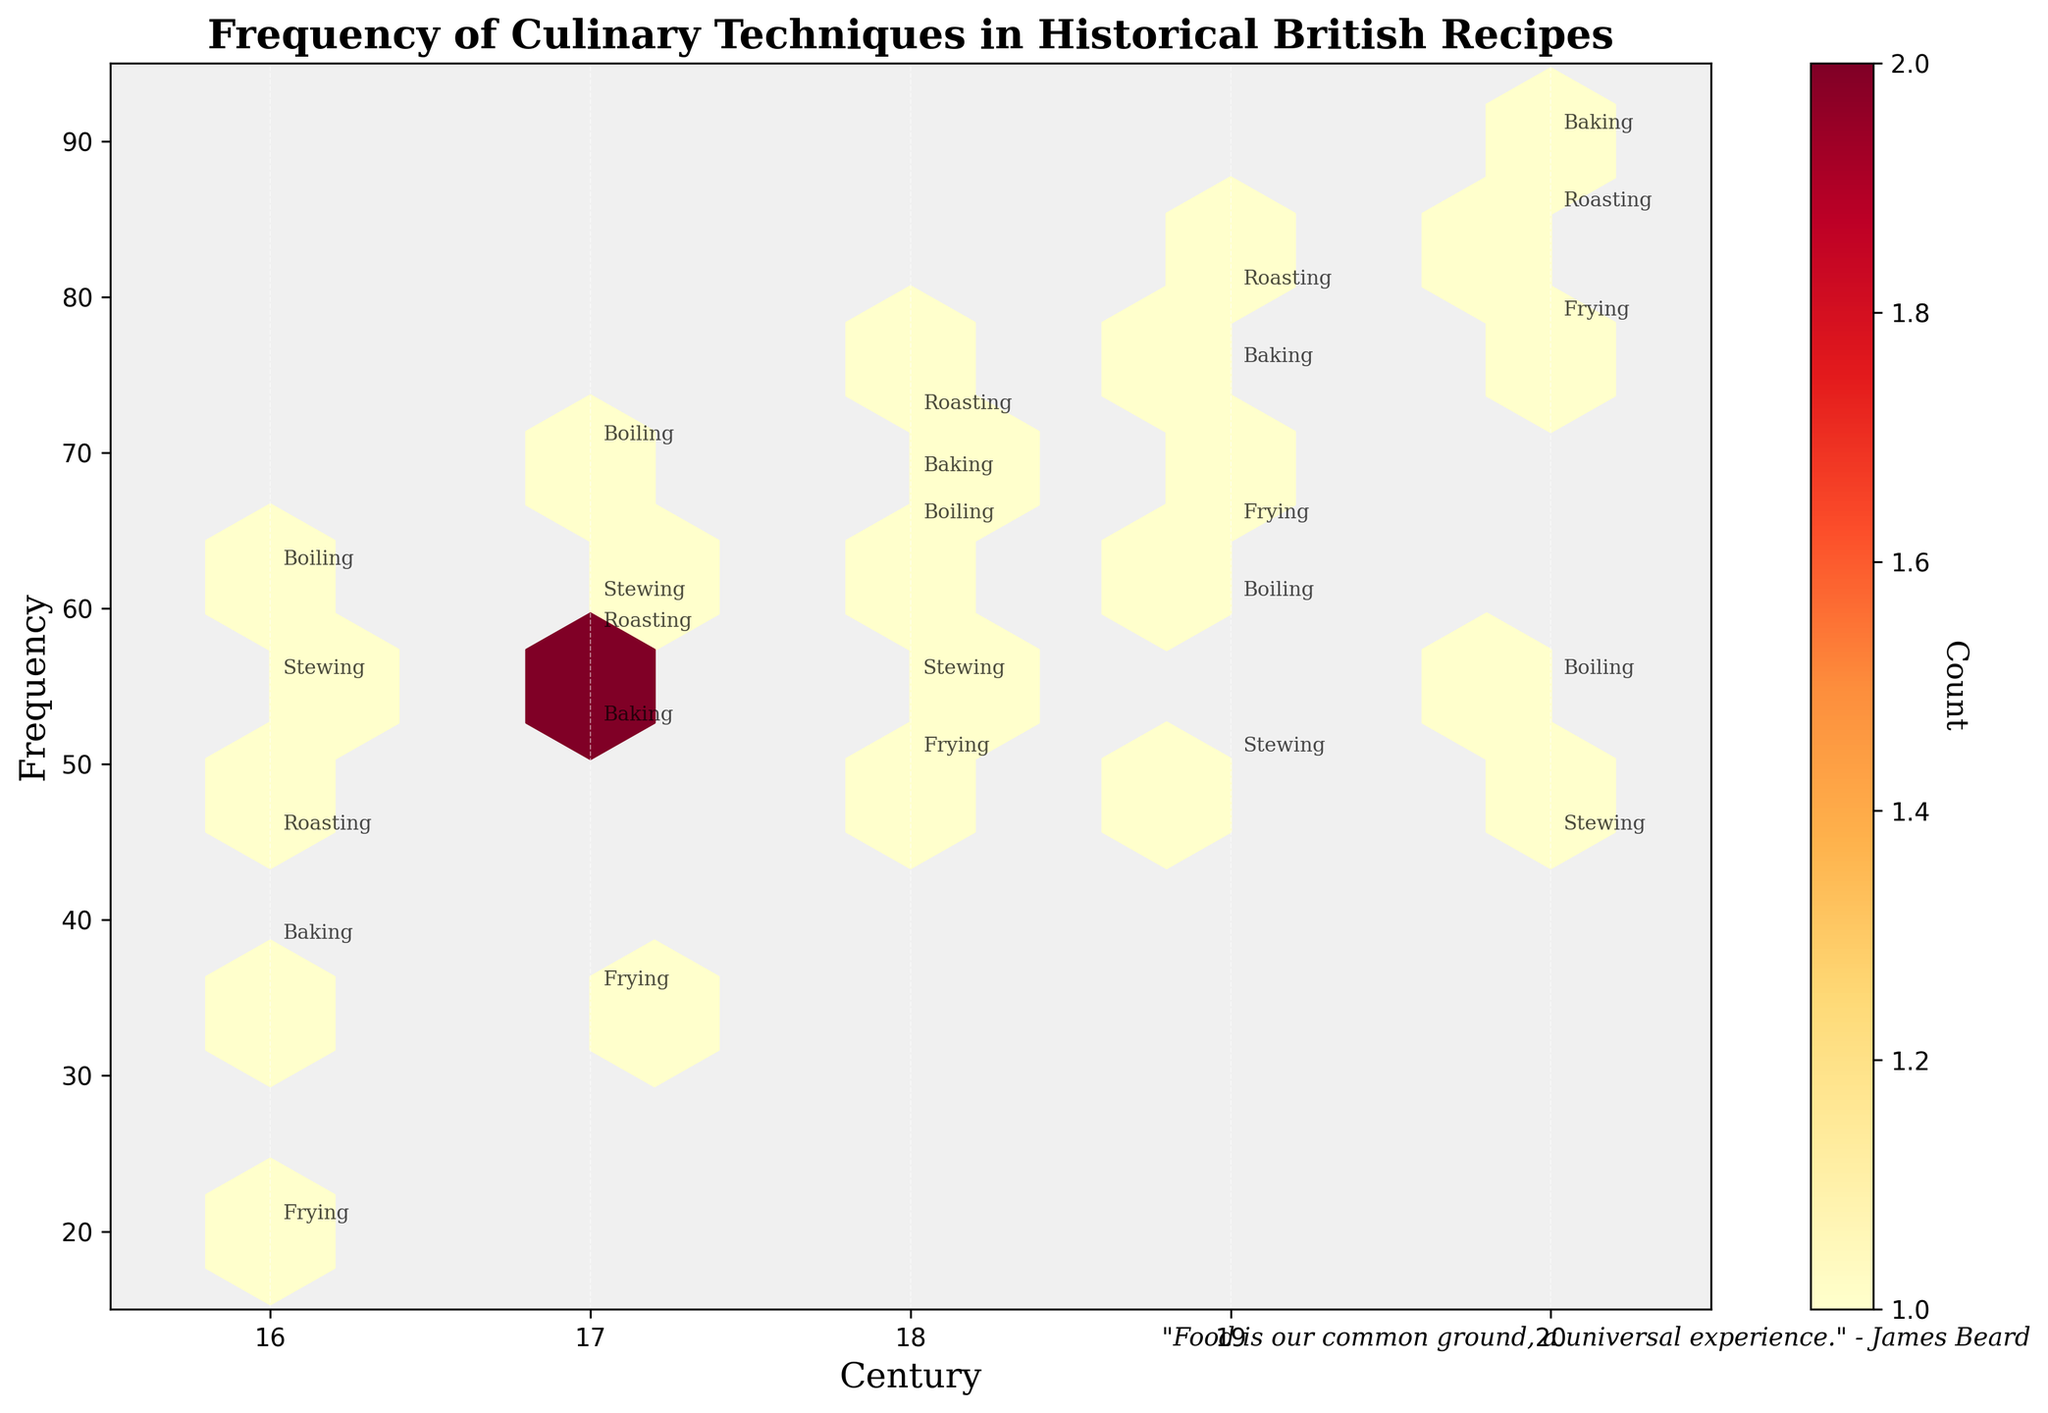What is the title of the plot? The title of the plot is displayed at the top, within the plot area itself. It reads: "Frequency of Culinary Techniques in Historical British Recipes".
Answer: Frequency of Culinary Techniques in Historical British Recipes What are the x-axis and y-axis labels? The x-axis label can be found below the x-axis line, reading "Century". Similarly, the y-axis label is located beside the y-axis line, reading "Frequency".
Answer: Century, Frequency Between which centuries does the plot show data? The x-axis presents values ranging between the years 16 and 20, indicating that the data is for the centuries from the 16th to the 20th.
Answer: 16th to 20th centuries Which century shows the highest frequency for baking? The label "Baking" closest to the highest point on the y-axis (90 units) falls in the plot area associated with the 20th century.
Answer: 20th century What is the range of frequencies captured on the y-axis? By examining the minimum and maximum values along the y-axis, which start at 15 and extend to 95.
Answer: 15 to 95 In which century is frying the least frequent? By identifying all occurrences of "Frying" labels and their positions on the x-axis, the lowest point for frying is in the 16th century, where it is 20.
Answer: 16th century What is the average frequency of roasting over the listed centuries? To determine the average, one needs to sum the frequencies of roasting (45, 58, 72, 80, 85) and then divide by the number of centuries (5). Calculated as (45 + 58 + 72 + 80 + 85) / 5 = 68.
Answer: 68 Which cooking technique has the most frequent use in the 19th century? Within the 19th-century plot section, identify the highest frequency labels. "Roasting" at 80 is the highest among the values listed.
Answer: Roasting Between the 18th and 19th centuries, which century shows a decrease in the frequency of boiling? By comparing the boiling values of both centuries, it's seen that the frequency decreases from 65 to 60 from the 18th to the 19th century.
Answer: 19th century What is the color scheme used in the hexbin plot? The hexbin color scheme varies from lighter shades to darker shades, denoted by the colors "YlOrRd" (Yellow, Orange, Red).
Answer: Yellow, Orange, Red 